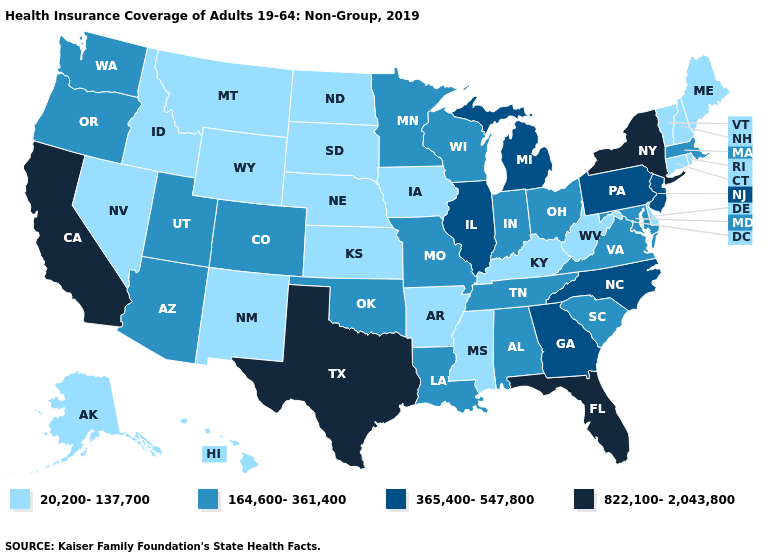Name the states that have a value in the range 164,600-361,400?
Keep it brief. Alabama, Arizona, Colorado, Indiana, Louisiana, Maryland, Massachusetts, Minnesota, Missouri, Ohio, Oklahoma, Oregon, South Carolina, Tennessee, Utah, Virginia, Washington, Wisconsin. What is the value of New Jersey?
Answer briefly. 365,400-547,800. What is the value of Indiana?
Give a very brief answer. 164,600-361,400. Name the states that have a value in the range 20,200-137,700?
Quick response, please. Alaska, Arkansas, Connecticut, Delaware, Hawaii, Idaho, Iowa, Kansas, Kentucky, Maine, Mississippi, Montana, Nebraska, Nevada, New Hampshire, New Mexico, North Dakota, Rhode Island, South Dakota, Vermont, West Virginia, Wyoming. What is the lowest value in the South?
Quick response, please. 20,200-137,700. Name the states that have a value in the range 365,400-547,800?
Be succinct. Georgia, Illinois, Michigan, New Jersey, North Carolina, Pennsylvania. Name the states that have a value in the range 164,600-361,400?
Give a very brief answer. Alabama, Arizona, Colorado, Indiana, Louisiana, Maryland, Massachusetts, Minnesota, Missouri, Ohio, Oklahoma, Oregon, South Carolina, Tennessee, Utah, Virginia, Washington, Wisconsin. Which states have the lowest value in the USA?
Short answer required. Alaska, Arkansas, Connecticut, Delaware, Hawaii, Idaho, Iowa, Kansas, Kentucky, Maine, Mississippi, Montana, Nebraska, Nevada, New Hampshire, New Mexico, North Dakota, Rhode Island, South Dakota, Vermont, West Virginia, Wyoming. Name the states that have a value in the range 20,200-137,700?
Short answer required. Alaska, Arkansas, Connecticut, Delaware, Hawaii, Idaho, Iowa, Kansas, Kentucky, Maine, Mississippi, Montana, Nebraska, Nevada, New Hampshire, New Mexico, North Dakota, Rhode Island, South Dakota, Vermont, West Virginia, Wyoming. Name the states that have a value in the range 164,600-361,400?
Quick response, please. Alabama, Arizona, Colorado, Indiana, Louisiana, Maryland, Massachusetts, Minnesota, Missouri, Ohio, Oklahoma, Oregon, South Carolina, Tennessee, Utah, Virginia, Washington, Wisconsin. What is the value of North Dakota?
Concise answer only. 20,200-137,700. Does New York have the highest value in the USA?
Answer briefly. Yes. Name the states that have a value in the range 164,600-361,400?
Give a very brief answer. Alabama, Arizona, Colorado, Indiana, Louisiana, Maryland, Massachusetts, Minnesota, Missouri, Ohio, Oklahoma, Oregon, South Carolina, Tennessee, Utah, Virginia, Washington, Wisconsin. Name the states that have a value in the range 164,600-361,400?
Short answer required. Alabama, Arizona, Colorado, Indiana, Louisiana, Maryland, Massachusetts, Minnesota, Missouri, Ohio, Oklahoma, Oregon, South Carolina, Tennessee, Utah, Virginia, Washington, Wisconsin. Which states have the lowest value in the USA?
Write a very short answer. Alaska, Arkansas, Connecticut, Delaware, Hawaii, Idaho, Iowa, Kansas, Kentucky, Maine, Mississippi, Montana, Nebraska, Nevada, New Hampshire, New Mexico, North Dakota, Rhode Island, South Dakota, Vermont, West Virginia, Wyoming. 